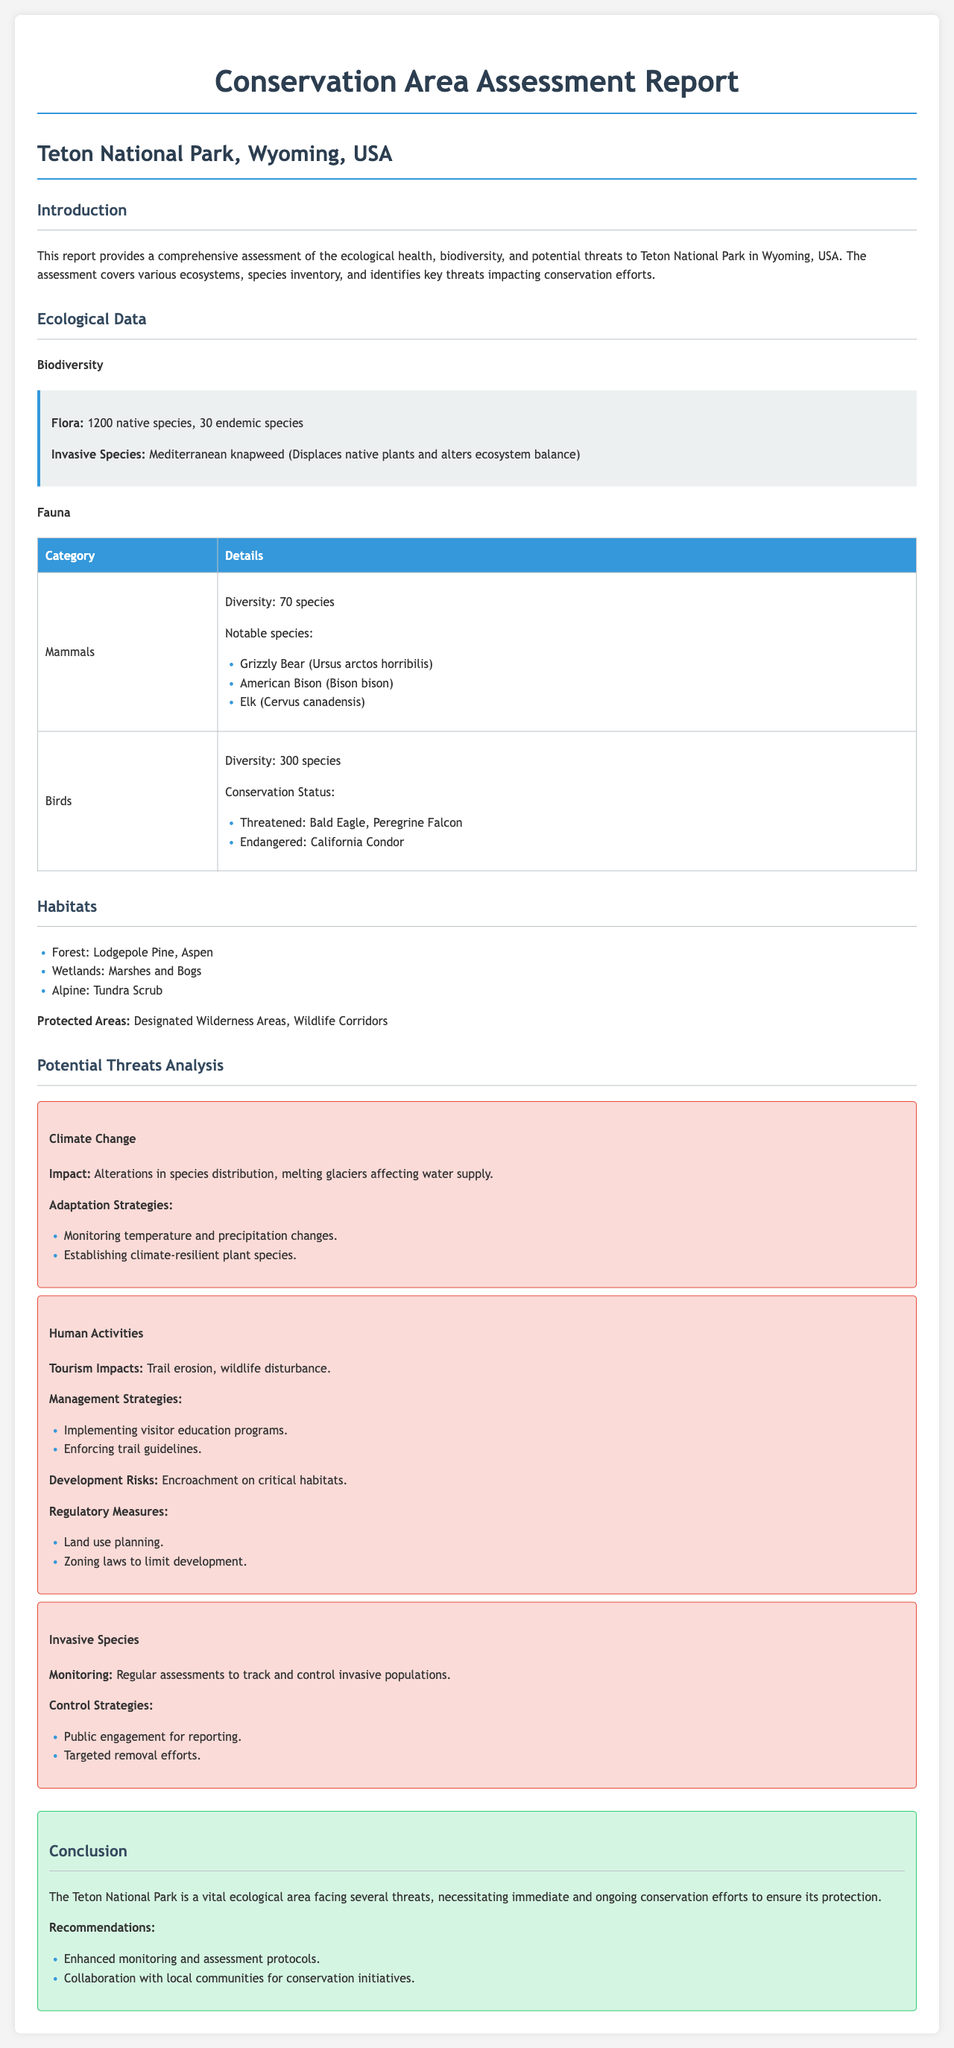What is the total number of native species in Teton National Park? The report states that there are 1200 native species in Teton National Park.
Answer: 1200 How many endemic species are identified in the park? The report indicates that there are 30 endemic species present in Teton National Park.
Answer: 30 What are the notable mammal species mentioned? The report lists Grizzly Bear, American Bison, and Elk as notable mammal species.
Answer: Grizzly Bear, American Bison, Elk Which bird species are listed as threatened? According to the report, the threatened bird species include the Bald Eagle and Peregrine Falcon.
Answer: Bald Eagle, Peregrine Falcon What is the main impact of climate change mentioned? The report identifies alterations in species distribution and melting glaciers affecting water supply as the main impacts.
Answer: Alterations in species distribution, melting glaciers What management strategy is suggested for controlling tourism impacts? The report suggests implementing visitor education programs to manage tourism impacts.
Answer: Visitor education programs What strategies are proposed for invasive species control? The report proposes public engagement for reporting and targeted removal efforts as control strategies.
Answer: Public engagement, targeted removal efforts What two recommendations are given in the conclusion? The report recommends enhanced monitoring and assessment protocols and collaboration with local communities for conservation initiatives.
Answer: Enhanced monitoring, collaboration with local communities 